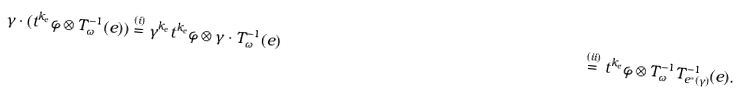Convert formula to latex. <formula><loc_0><loc_0><loc_500><loc_500>\gamma \cdot ( t ^ { k _ { e } } \varphi \otimes T ^ { - 1 } _ { \omega } ( e ) ) & \stackrel { ( i ) } { = } \gamma ^ { k _ { e } } t ^ { k _ { e } } \varphi \otimes \gamma \cdot T ^ { - 1 } _ { \omega } ( e ) & \stackrel { ( i i ) } { = } t ^ { k _ { e } } \varphi \otimes T ^ { - 1 } _ { \omega } T ^ { - 1 } _ { e ^ { * } ( \gamma ) } ( e ) .</formula> 